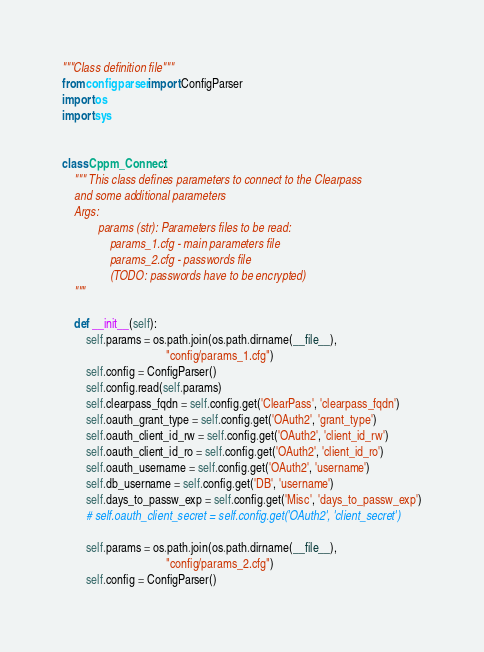<code> <loc_0><loc_0><loc_500><loc_500><_Python_>"""Class definition file"""
from configparser import ConfigParser
import os
import sys


class Cppm_Connect:
    """ This class defines parameters to connect to the Clearpass 
    and some additional parameters
    Args:
            params (str): Parameters files to be read:
                params_1.cfg - main parameters file
                params_2.cfg - passwords file
                (TODO: passwords have to be encrypted)
    """

    def __init__(self):
        self.params = os.path.join(os.path.dirname(__file__),
                                   "config/params_1.cfg")
        self.config = ConfigParser()
        self.config.read(self.params)
        self.clearpass_fqdn = self.config.get('ClearPass', 'clearpass_fqdn')
        self.oauth_grant_type = self.config.get('OAuth2', 'grant_type')
        self.oauth_client_id_rw = self.config.get('OAuth2', 'client_id_rw')
        self.oauth_client_id_ro = self.config.get('OAuth2', 'client_id_ro')
        self.oauth_username = self.config.get('OAuth2', 'username')
        self.db_username = self.config.get('DB', 'username')
        self.days_to_passw_exp = self.config.get('Misc', 'days_to_passw_exp')
        # self.oauth_client_secret = self.config.get('OAuth2', 'client_secret')

        self.params = os.path.join(os.path.dirname(__file__),
                                   "config/params_2.cfg")
        self.config = ConfigParser()</code> 